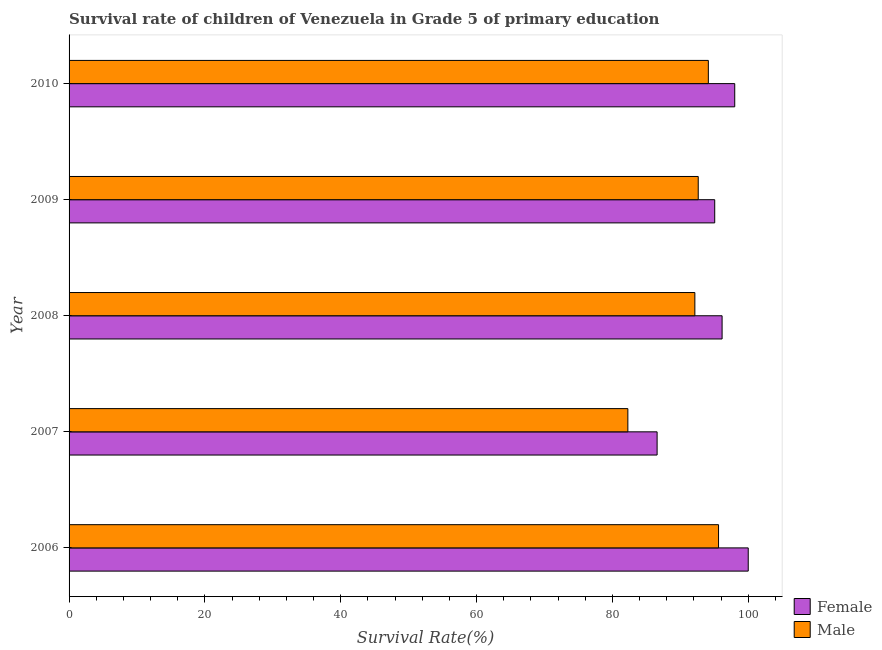How many groups of bars are there?
Your response must be concise. 5. Are the number of bars on each tick of the Y-axis equal?
Offer a terse response. Yes. How many bars are there on the 4th tick from the top?
Give a very brief answer. 2. What is the survival rate of male students in primary education in 2010?
Provide a short and direct response. 94.13. Across all years, what is the minimum survival rate of male students in primary education?
Provide a succinct answer. 82.28. What is the total survival rate of male students in primary education in the graph?
Keep it short and to the point. 456.81. What is the difference between the survival rate of male students in primary education in 2006 and that in 2008?
Provide a succinct answer. 3.49. What is the difference between the survival rate of female students in primary education in 2010 and the survival rate of male students in primary education in 2006?
Keep it short and to the point. 2.38. What is the average survival rate of female students in primary education per year?
Offer a terse response. 95.16. In the year 2010, what is the difference between the survival rate of female students in primary education and survival rate of male students in primary education?
Make the answer very short. 3.88. In how many years, is the survival rate of male students in primary education greater than 80 %?
Your response must be concise. 5. What is the ratio of the survival rate of female students in primary education in 2006 to that in 2007?
Make the answer very short. 1.16. What is the difference between the highest and the second highest survival rate of female students in primary education?
Offer a very short reply. 1.99. What is the difference between the highest and the lowest survival rate of male students in primary education?
Give a very brief answer. 13.35. Is the sum of the survival rate of female students in primary education in 2007 and 2009 greater than the maximum survival rate of male students in primary education across all years?
Your answer should be very brief. Yes. Are all the bars in the graph horizontal?
Keep it short and to the point. Yes. How many years are there in the graph?
Offer a terse response. 5. What is the difference between two consecutive major ticks on the X-axis?
Your answer should be very brief. 20. Are the values on the major ticks of X-axis written in scientific E-notation?
Offer a very short reply. No. Where does the legend appear in the graph?
Provide a short and direct response. Bottom right. How many legend labels are there?
Provide a succinct answer. 2. How are the legend labels stacked?
Keep it short and to the point. Vertical. What is the title of the graph?
Provide a short and direct response. Survival rate of children of Venezuela in Grade 5 of primary education. Does "Grants" appear as one of the legend labels in the graph?
Your answer should be very brief. No. What is the label or title of the X-axis?
Give a very brief answer. Survival Rate(%). What is the label or title of the Y-axis?
Ensure brevity in your answer.  Year. What is the Survival Rate(%) of Female in 2006?
Your response must be concise. 100. What is the Survival Rate(%) of Male in 2006?
Your answer should be compact. 95.63. What is the Survival Rate(%) in Female in 2007?
Ensure brevity in your answer.  86.58. What is the Survival Rate(%) in Male in 2007?
Provide a short and direct response. 82.28. What is the Survival Rate(%) in Female in 2008?
Your answer should be very brief. 96.15. What is the Survival Rate(%) of Male in 2008?
Your answer should be compact. 92.14. What is the Survival Rate(%) in Female in 2009?
Ensure brevity in your answer.  95.07. What is the Survival Rate(%) of Male in 2009?
Make the answer very short. 92.64. What is the Survival Rate(%) of Female in 2010?
Make the answer very short. 98.01. What is the Survival Rate(%) of Male in 2010?
Keep it short and to the point. 94.13. Across all years, what is the maximum Survival Rate(%) of Female?
Offer a very short reply. 100. Across all years, what is the maximum Survival Rate(%) of Male?
Your response must be concise. 95.63. Across all years, what is the minimum Survival Rate(%) in Female?
Ensure brevity in your answer.  86.58. Across all years, what is the minimum Survival Rate(%) of Male?
Ensure brevity in your answer.  82.28. What is the total Survival Rate(%) of Female in the graph?
Provide a succinct answer. 475.81. What is the total Survival Rate(%) in Male in the graph?
Provide a short and direct response. 456.81. What is the difference between the Survival Rate(%) of Female in 2006 and that in 2007?
Your response must be concise. 13.42. What is the difference between the Survival Rate(%) in Male in 2006 and that in 2007?
Your answer should be very brief. 13.35. What is the difference between the Survival Rate(%) in Female in 2006 and that in 2008?
Give a very brief answer. 3.85. What is the difference between the Survival Rate(%) of Male in 2006 and that in 2008?
Offer a terse response. 3.49. What is the difference between the Survival Rate(%) of Female in 2006 and that in 2009?
Provide a succinct answer. 4.93. What is the difference between the Survival Rate(%) in Male in 2006 and that in 2009?
Make the answer very short. 2.99. What is the difference between the Survival Rate(%) of Female in 2006 and that in 2010?
Offer a very short reply. 1.99. What is the difference between the Survival Rate(%) of Male in 2006 and that in 2010?
Make the answer very short. 1.5. What is the difference between the Survival Rate(%) in Female in 2007 and that in 2008?
Provide a short and direct response. -9.57. What is the difference between the Survival Rate(%) in Male in 2007 and that in 2008?
Provide a short and direct response. -9.87. What is the difference between the Survival Rate(%) in Female in 2007 and that in 2009?
Provide a short and direct response. -8.48. What is the difference between the Survival Rate(%) of Male in 2007 and that in 2009?
Offer a very short reply. -10.36. What is the difference between the Survival Rate(%) in Female in 2007 and that in 2010?
Your answer should be very brief. -11.43. What is the difference between the Survival Rate(%) in Male in 2007 and that in 2010?
Offer a very short reply. -11.85. What is the difference between the Survival Rate(%) of Female in 2008 and that in 2009?
Make the answer very short. 1.09. What is the difference between the Survival Rate(%) of Male in 2008 and that in 2009?
Your answer should be very brief. -0.5. What is the difference between the Survival Rate(%) in Female in 2008 and that in 2010?
Keep it short and to the point. -1.86. What is the difference between the Survival Rate(%) of Male in 2008 and that in 2010?
Provide a succinct answer. -1.99. What is the difference between the Survival Rate(%) in Female in 2009 and that in 2010?
Offer a very short reply. -2.95. What is the difference between the Survival Rate(%) in Male in 2009 and that in 2010?
Make the answer very short. -1.49. What is the difference between the Survival Rate(%) of Female in 2006 and the Survival Rate(%) of Male in 2007?
Provide a short and direct response. 17.73. What is the difference between the Survival Rate(%) in Female in 2006 and the Survival Rate(%) in Male in 2008?
Your answer should be compact. 7.86. What is the difference between the Survival Rate(%) in Female in 2006 and the Survival Rate(%) in Male in 2009?
Provide a short and direct response. 7.36. What is the difference between the Survival Rate(%) in Female in 2006 and the Survival Rate(%) in Male in 2010?
Offer a very short reply. 5.87. What is the difference between the Survival Rate(%) in Female in 2007 and the Survival Rate(%) in Male in 2008?
Your answer should be compact. -5.56. What is the difference between the Survival Rate(%) of Female in 2007 and the Survival Rate(%) of Male in 2009?
Provide a short and direct response. -6.05. What is the difference between the Survival Rate(%) in Female in 2007 and the Survival Rate(%) in Male in 2010?
Your response must be concise. -7.54. What is the difference between the Survival Rate(%) in Female in 2008 and the Survival Rate(%) in Male in 2009?
Your response must be concise. 3.51. What is the difference between the Survival Rate(%) of Female in 2008 and the Survival Rate(%) of Male in 2010?
Your answer should be very brief. 2.02. What is the difference between the Survival Rate(%) in Female in 2009 and the Survival Rate(%) in Male in 2010?
Your answer should be very brief. 0.94. What is the average Survival Rate(%) of Female per year?
Make the answer very short. 95.16. What is the average Survival Rate(%) in Male per year?
Offer a terse response. 91.36. In the year 2006, what is the difference between the Survival Rate(%) in Female and Survival Rate(%) in Male?
Your answer should be very brief. 4.37. In the year 2007, what is the difference between the Survival Rate(%) of Female and Survival Rate(%) of Male?
Provide a short and direct response. 4.31. In the year 2008, what is the difference between the Survival Rate(%) in Female and Survival Rate(%) in Male?
Your answer should be compact. 4.01. In the year 2009, what is the difference between the Survival Rate(%) in Female and Survival Rate(%) in Male?
Provide a succinct answer. 2.43. In the year 2010, what is the difference between the Survival Rate(%) of Female and Survival Rate(%) of Male?
Make the answer very short. 3.88. What is the ratio of the Survival Rate(%) of Female in 2006 to that in 2007?
Make the answer very short. 1.16. What is the ratio of the Survival Rate(%) of Male in 2006 to that in 2007?
Provide a short and direct response. 1.16. What is the ratio of the Survival Rate(%) of Female in 2006 to that in 2008?
Ensure brevity in your answer.  1.04. What is the ratio of the Survival Rate(%) of Male in 2006 to that in 2008?
Offer a terse response. 1.04. What is the ratio of the Survival Rate(%) of Female in 2006 to that in 2009?
Your response must be concise. 1.05. What is the ratio of the Survival Rate(%) of Male in 2006 to that in 2009?
Provide a short and direct response. 1.03. What is the ratio of the Survival Rate(%) in Female in 2006 to that in 2010?
Your answer should be compact. 1.02. What is the ratio of the Survival Rate(%) in Male in 2006 to that in 2010?
Give a very brief answer. 1.02. What is the ratio of the Survival Rate(%) of Female in 2007 to that in 2008?
Provide a short and direct response. 0.9. What is the ratio of the Survival Rate(%) of Male in 2007 to that in 2008?
Your answer should be compact. 0.89. What is the ratio of the Survival Rate(%) of Female in 2007 to that in 2009?
Your response must be concise. 0.91. What is the ratio of the Survival Rate(%) in Male in 2007 to that in 2009?
Offer a terse response. 0.89. What is the ratio of the Survival Rate(%) in Female in 2007 to that in 2010?
Provide a short and direct response. 0.88. What is the ratio of the Survival Rate(%) in Male in 2007 to that in 2010?
Your answer should be very brief. 0.87. What is the ratio of the Survival Rate(%) in Female in 2008 to that in 2009?
Your answer should be very brief. 1.01. What is the ratio of the Survival Rate(%) in Male in 2008 to that in 2009?
Provide a succinct answer. 0.99. What is the ratio of the Survival Rate(%) in Female in 2008 to that in 2010?
Offer a very short reply. 0.98. What is the ratio of the Survival Rate(%) in Male in 2008 to that in 2010?
Ensure brevity in your answer.  0.98. What is the ratio of the Survival Rate(%) in Female in 2009 to that in 2010?
Give a very brief answer. 0.97. What is the ratio of the Survival Rate(%) of Male in 2009 to that in 2010?
Your answer should be compact. 0.98. What is the difference between the highest and the second highest Survival Rate(%) in Female?
Give a very brief answer. 1.99. What is the difference between the highest and the second highest Survival Rate(%) of Male?
Keep it short and to the point. 1.5. What is the difference between the highest and the lowest Survival Rate(%) in Female?
Ensure brevity in your answer.  13.42. What is the difference between the highest and the lowest Survival Rate(%) in Male?
Keep it short and to the point. 13.35. 